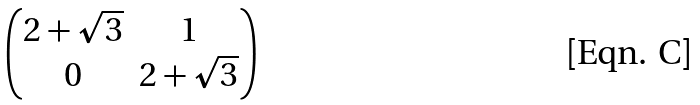<formula> <loc_0><loc_0><loc_500><loc_500>\begin{pmatrix} 2 + \sqrt { 3 } & 1 \\ 0 & 2 + \sqrt { 3 } \end{pmatrix}</formula> 